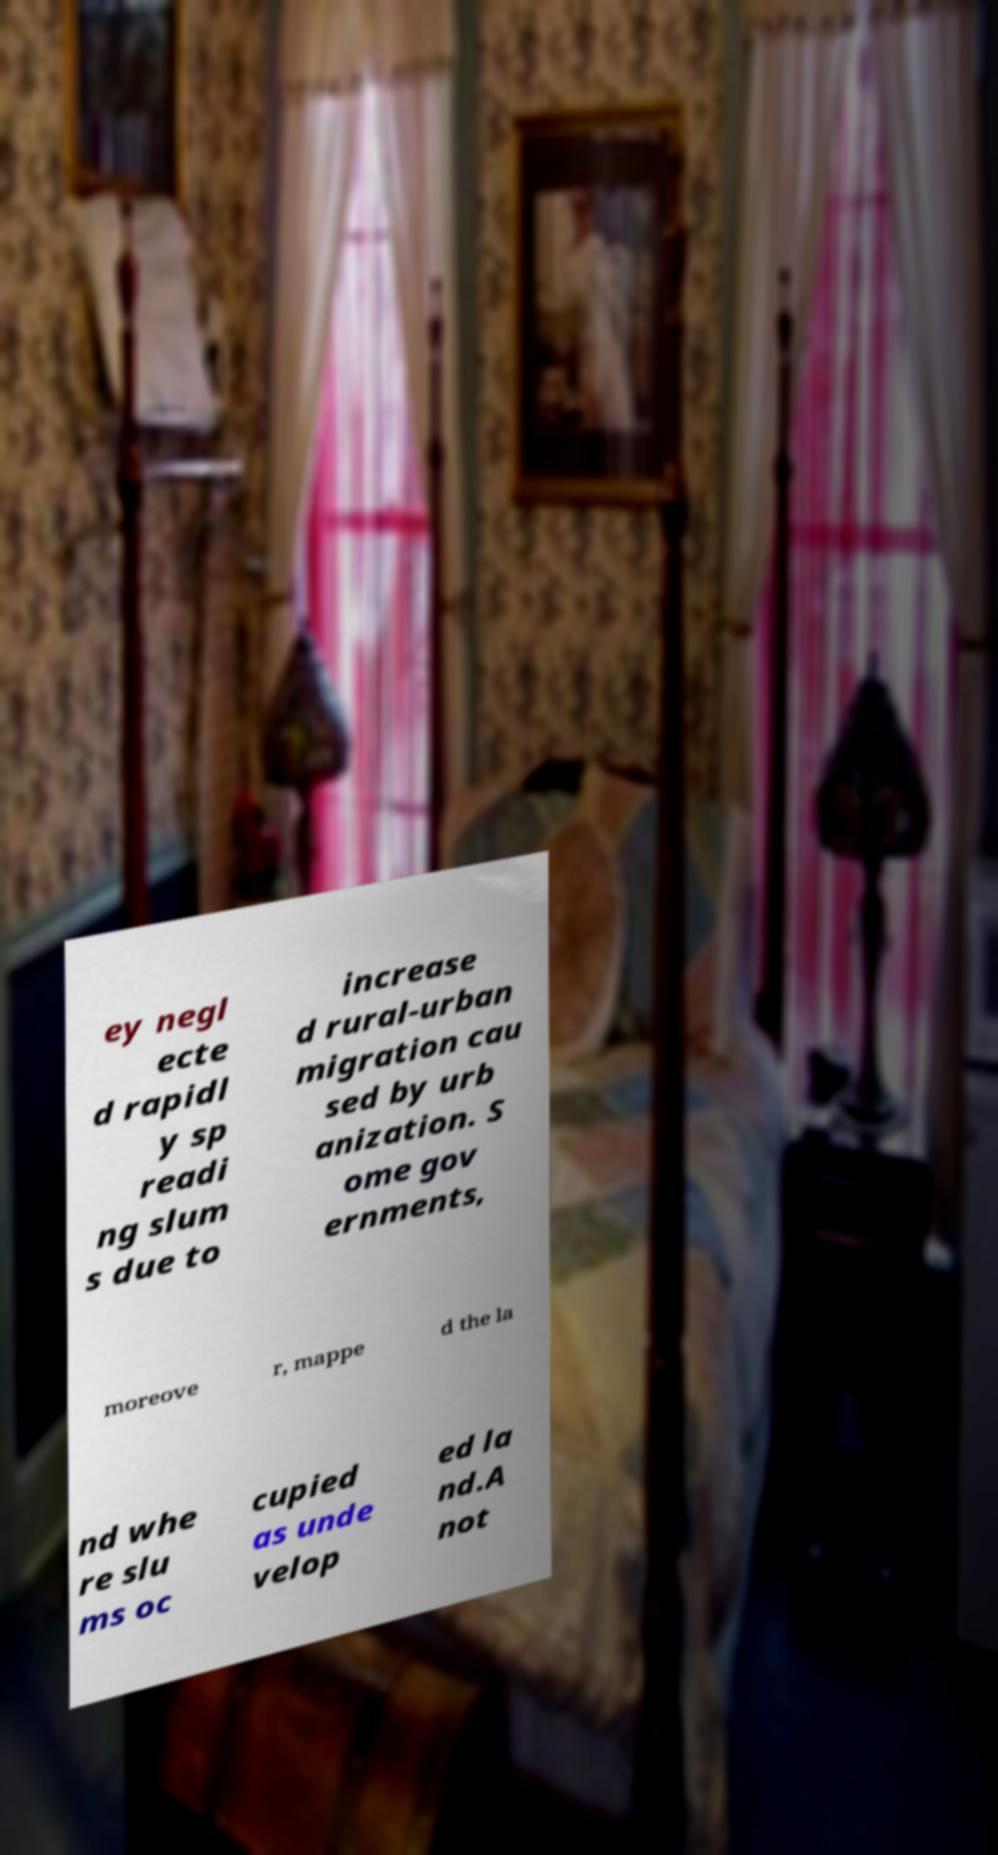Please read and relay the text visible in this image. What does it say? ey negl ecte d rapidl y sp readi ng slum s due to increase d rural-urban migration cau sed by urb anization. S ome gov ernments, moreove r, mappe d the la nd whe re slu ms oc cupied as unde velop ed la nd.A not 